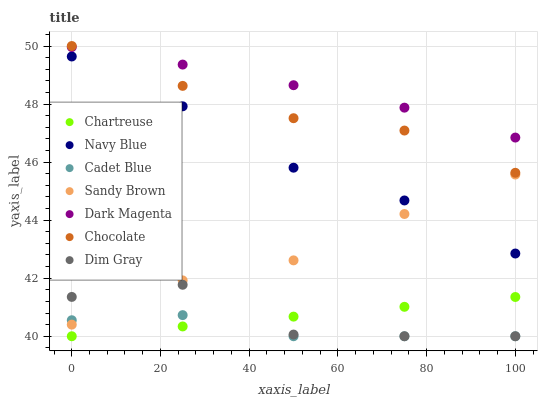Does Cadet Blue have the minimum area under the curve?
Answer yes or no. Yes. Does Dark Magenta have the maximum area under the curve?
Answer yes or no. Yes. Does Navy Blue have the minimum area under the curve?
Answer yes or no. No. Does Navy Blue have the maximum area under the curve?
Answer yes or no. No. Is Chartreuse the smoothest?
Answer yes or no. Yes. Is Dim Gray the roughest?
Answer yes or no. Yes. Is Dark Magenta the smoothest?
Answer yes or no. No. Is Dark Magenta the roughest?
Answer yes or no. No. Does Cadet Blue have the lowest value?
Answer yes or no. Yes. Does Navy Blue have the lowest value?
Answer yes or no. No. Does Chocolate have the highest value?
Answer yes or no. Yes. Does Dark Magenta have the highest value?
Answer yes or no. No. Is Navy Blue less than Dark Magenta?
Answer yes or no. Yes. Is Chocolate greater than Navy Blue?
Answer yes or no. Yes. Does Cadet Blue intersect Sandy Brown?
Answer yes or no. Yes. Is Cadet Blue less than Sandy Brown?
Answer yes or no. No. Is Cadet Blue greater than Sandy Brown?
Answer yes or no. No. Does Navy Blue intersect Dark Magenta?
Answer yes or no. No. 